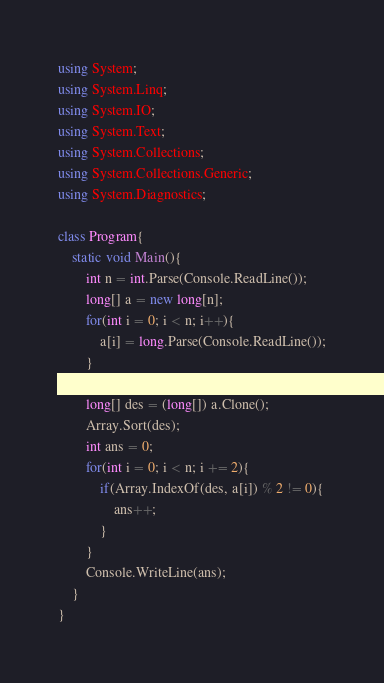<code> <loc_0><loc_0><loc_500><loc_500><_C#_>using System;
using System.Linq;
using System.IO;
using System.Text;
using System.Collections;
using System.Collections.Generic;
using System.Diagnostics;
 
class Program{
    static void Main(){
        int n = int.Parse(Console.ReadLine());
        long[] a = new long[n];
        for(int i = 0; i < n; i++){
            a[i] = long.Parse(Console.ReadLine());
        }

        long[] des = (long[]) a.Clone();
        Array.Sort(des);
        int ans = 0;
        for(int i = 0; i < n; i += 2){
            if(Array.IndexOf(des, a[i]) % 2 != 0){
                ans++;
            }
        }
        Console.WriteLine(ans);
    }
}</code> 